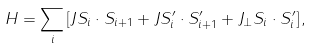Convert formula to latex. <formula><loc_0><loc_0><loc_500><loc_500>H = \sum _ { i } { [ J { S } _ { i } \cdot { S } _ { i + 1 } + J { S } _ { i } ^ { \prime } \cdot { S } ^ { \prime } _ { i + 1 } + J _ { \perp } { S } _ { i } \cdot { S } ^ { \prime } _ { i } ] } \, ,</formula> 